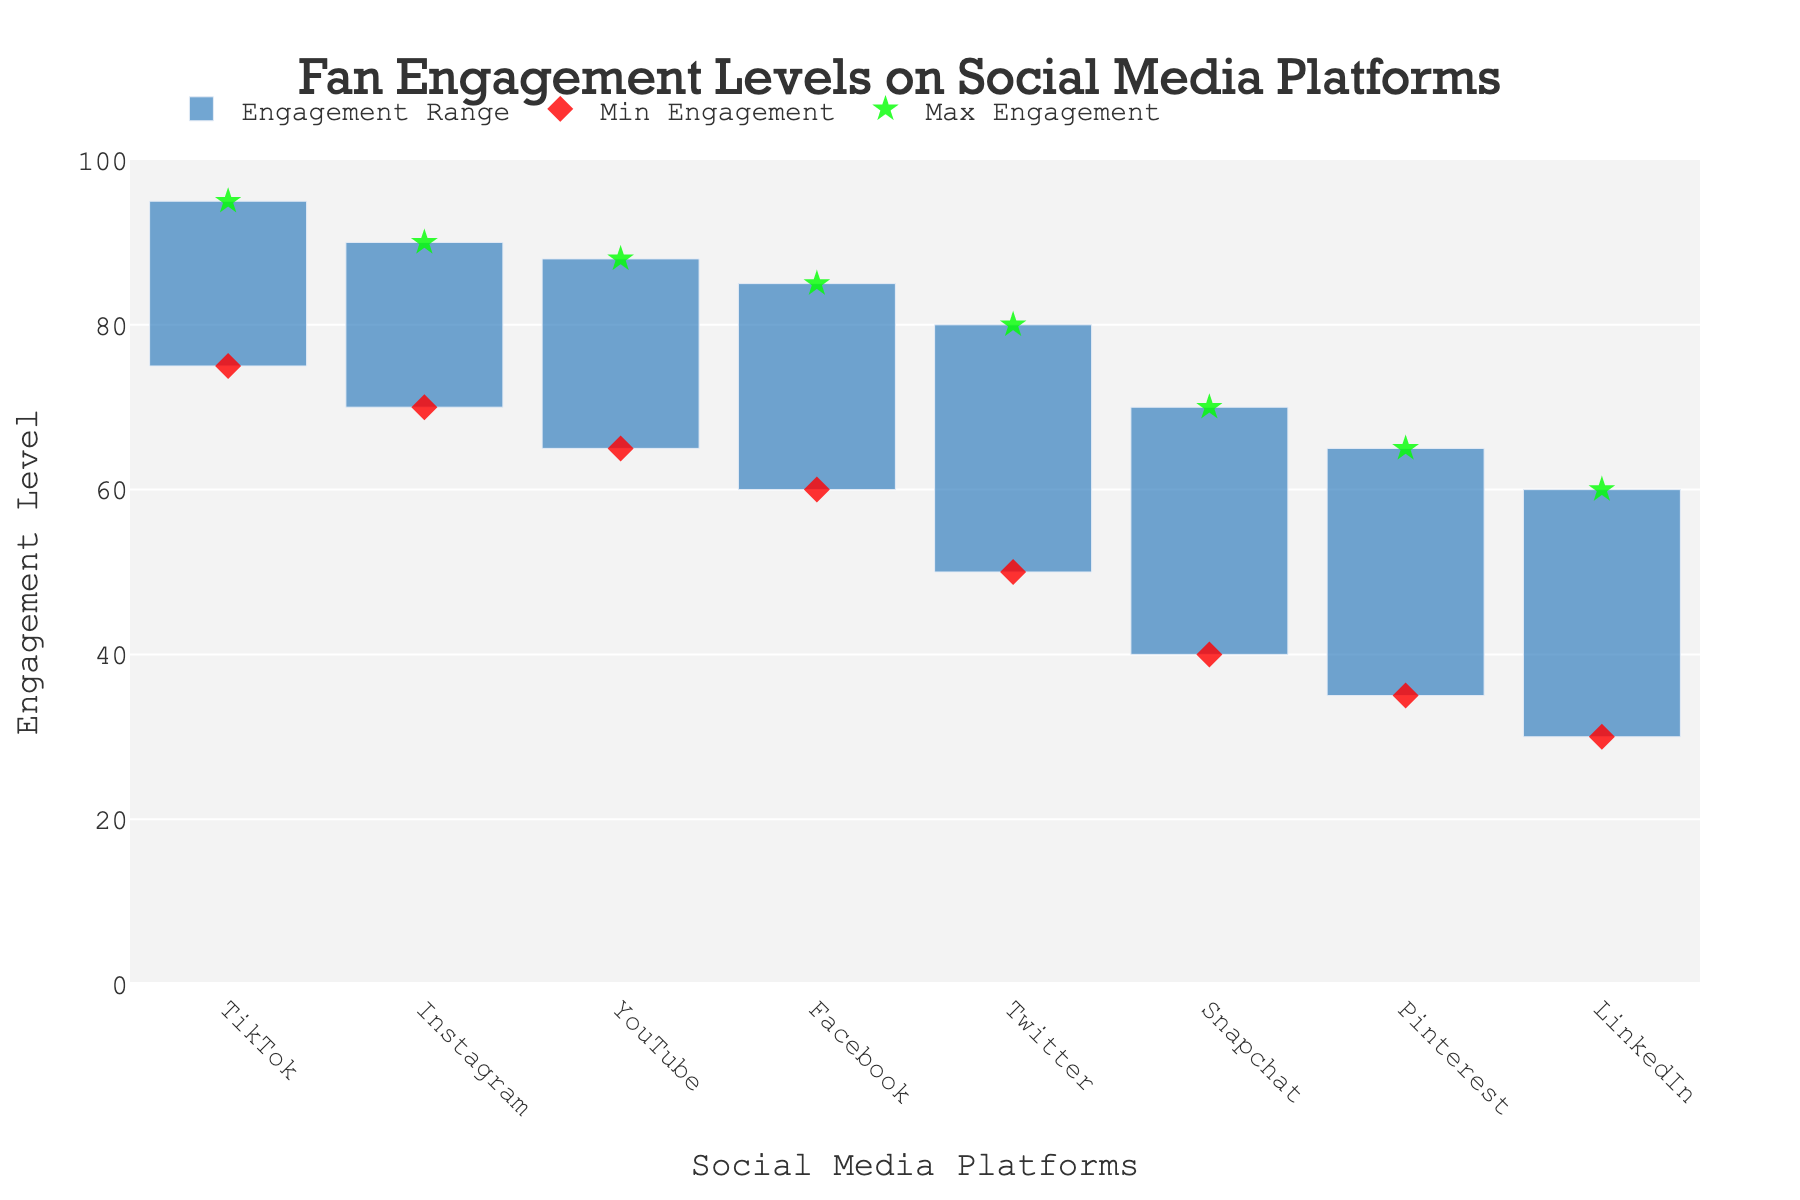What's the title of the plot? The title is shown at the top of the plot in a larger and more prominent font.
Answer: Fan Engagement Levels on Social Media Platforms Which platform has the highest maximum engagement level? The plot shows the maximum engagement levels using green star markers. TikTok reaches the highest point.
Answer: TikTok What is the range of fan engagement levels on Facebook? The range of engagement levels is represented by the bar starting at the minimum engagement level and ending at the maximum engagement level. For Facebook, these are 60 and 85, respectively. The range is 85 - 60.
Answer: 25 How many platforms have a minimum engagement level below 50? By checking the red diamond markers, which indicate the minimum engagement levels, we can identify LinkedIn, Pinterest, and Snapchat as having minimum levels below 50.
Answer: Three Which platform has the smallest range of fan engagement levels? The range is identified by the length of the bars. The smallest range bar corresponds to LinkedIn.
Answer: LinkedIn Compare the maximum engagement levels of Snapchat and Instagram. Which one is higher? The maximum engagement levels for these platforms are indicated by green stars. Instagram's maximum is 90, while Snapchat's is 70, so Instagram's is higher.
Answer: Instagram What is the difference between the maximum engagement levels of YouTube and Pinterest? Identify YouTube's and Pinterest's maximum levels (88 and 65) and compute the difference: 88 - 65.
Answer: 23 Which platforms have a maximum engagement level between 80 and 90? The plot shows maximum engagement levels via green stars. The platforms within this range are Facebook, YouTube, and Instagram.
Answer: Facebook, YouTube, Instagram What is the average of the minimum engagement levels for TikTok and Twitter? Sum the minimum engagement levels for TikTok and Twitter (75 and 50), then divide by 2. (75 + 50) / 2 = 62.5
Answer: 62.5 Which platform has the largest difference between its minimum and maximum engagement levels? The longest bar represents the largest difference between minimum and maximum engagement levels. TikTok has the longest bar.
Answer: TikTok 